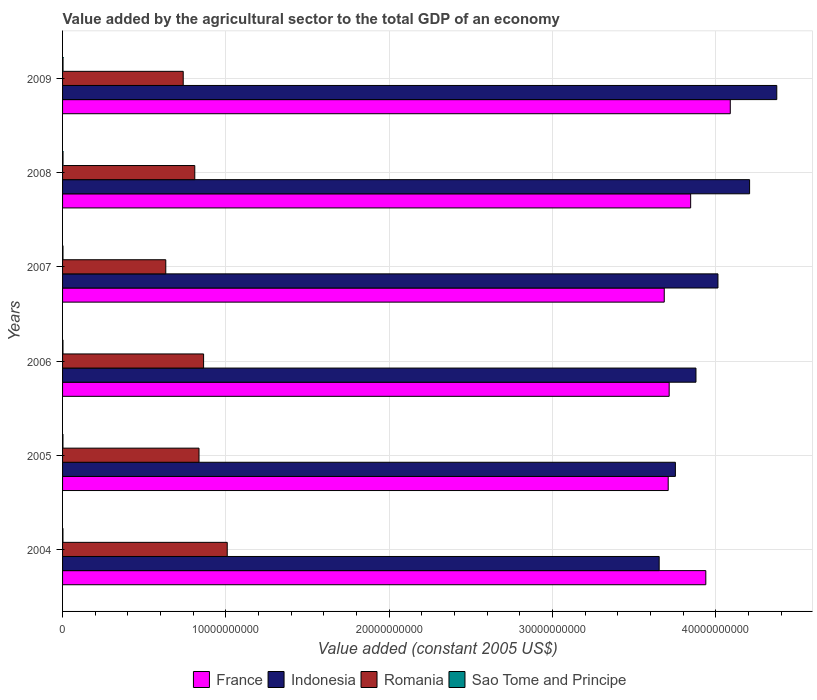How many different coloured bars are there?
Give a very brief answer. 4. How many groups of bars are there?
Your answer should be very brief. 6. Are the number of bars on each tick of the Y-axis equal?
Your answer should be compact. Yes. How many bars are there on the 1st tick from the bottom?
Provide a succinct answer. 4. What is the label of the 5th group of bars from the top?
Ensure brevity in your answer.  2005. In how many cases, is the number of bars for a given year not equal to the number of legend labels?
Provide a succinct answer. 0. What is the value added by the agricultural sector in France in 2004?
Ensure brevity in your answer.  3.94e+1. Across all years, what is the maximum value added by the agricultural sector in Indonesia?
Keep it short and to the point. 4.37e+1. Across all years, what is the minimum value added by the agricultural sector in Romania?
Provide a succinct answer. 6.32e+09. In which year was the value added by the agricultural sector in Romania minimum?
Offer a very short reply. 2007. What is the total value added by the agricultural sector in Indonesia in the graph?
Your answer should be very brief. 2.39e+11. What is the difference between the value added by the agricultural sector in Sao Tome and Principe in 2004 and that in 2007?
Ensure brevity in your answer.  -2.40e+06. What is the difference between the value added by the agricultural sector in Indonesia in 2006 and the value added by the agricultural sector in Romania in 2005?
Offer a terse response. 3.04e+1. What is the average value added by the agricultural sector in Indonesia per year?
Provide a succinct answer. 3.98e+1. In the year 2009, what is the difference between the value added by the agricultural sector in Sao Tome and Principe and value added by the agricultural sector in France?
Your answer should be compact. -4.09e+1. In how many years, is the value added by the agricultural sector in France greater than 42000000000 US$?
Offer a terse response. 0. What is the ratio of the value added by the agricultural sector in France in 2005 to that in 2007?
Provide a succinct answer. 1.01. Is the difference between the value added by the agricultural sector in Sao Tome and Principe in 2005 and 2009 greater than the difference between the value added by the agricultural sector in France in 2005 and 2009?
Keep it short and to the point. Yes. What is the difference between the highest and the second highest value added by the agricultural sector in Sao Tome and Principe?
Offer a terse response. 1.07e+06. What is the difference between the highest and the lowest value added by the agricultural sector in France?
Your response must be concise. 4.04e+09. Is the sum of the value added by the agricultural sector in Sao Tome and Principe in 2007 and 2009 greater than the maximum value added by the agricultural sector in Indonesia across all years?
Your answer should be very brief. No. Is it the case that in every year, the sum of the value added by the agricultural sector in Indonesia and value added by the agricultural sector in Romania is greater than the sum of value added by the agricultural sector in Sao Tome and Principe and value added by the agricultural sector in France?
Offer a very short reply. No. Is it the case that in every year, the sum of the value added by the agricultural sector in Sao Tome and Principe and value added by the agricultural sector in Romania is greater than the value added by the agricultural sector in France?
Your answer should be compact. No. Are the values on the major ticks of X-axis written in scientific E-notation?
Your answer should be compact. No. Does the graph contain any zero values?
Give a very brief answer. No. Does the graph contain grids?
Provide a short and direct response. Yes. Where does the legend appear in the graph?
Offer a terse response. Bottom center. How many legend labels are there?
Your answer should be compact. 4. What is the title of the graph?
Keep it short and to the point. Value added by the agricultural sector to the total GDP of an economy. Does "Nigeria" appear as one of the legend labels in the graph?
Keep it short and to the point. No. What is the label or title of the X-axis?
Your answer should be compact. Value added (constant 2005 US$). What is the label or title of the Y-axis?
Make the answer very short. Years. What is the Value added (constant 2005 US$) of France in 2004?
Your answer should be compact. 3.94e+1. What is the Value added (constant 2005 US$) of Indonesia in 2004?
Offer a very short reply. 3.65e+1. What is the Value added (constant 2005 US$) in Romania in 2004?
Make the answer very short. 1.01e+1. What is the Value added (constant 2005 US$) in Sao Tome and Principe in 2004?
Give a very brief answer. 2.29e+07. What is the Value added (constant 2005 US$) of France in 2005?
Offer a very short reply. 3.71e+1. What is the Value added (constant 2005 US$) in Indonesia in 2005?
Your answer should be very brief. 3.75e+1. What is the Value added (constant 2005 US$) of Romania in 2005?
Make the answer very short. 8.35e+09. What is the Value added (constant 2005 US$) in Sao Tome and Principe in 2005?
Provide a short and direct response. 2.33e+07. What is the Value added (constant 2005 US$) of France in 2006?
Your response must be concise. 3.71e+1. What is the Value added (constant 2005 US$) in Indonesia in 2006?
Provide a short and direct response. 3.88e+1. What is the Value added (constant 2005 US$) in Romania in 2006?
Your answer should be compact. 8.64e+09. What is the Value added (constant 2005 US$) of Sao Tome and Principe in 2006?
Make the answer very short. 2.46e+07. What is the Value added (constant 2005 US$) of France in 2007?
Offer a terse response. 3.68e+1. What is the Value added (constant 2005 US$) of Indonesia in 2007?
Your response must be concise. 4.01e+1. What is the Value added (constant 2005 US$) in Romania in 2007?
Your answer should be very brief. 6.32e+09. What is the Value added (constant 2005 US$) of Sao Tome and Principe in 2007?
Give a very brief answer. 2.53e+07. What is the Value added (constant 2005 US$) of France in 2008?
Your answer should be very brief. 3.85e+1. What is the Value added (constant 2005 US$) of Indonesia in 2008?
Give a very brief answer. 4.21e+1. What is the Value added (constant 2005 US$) of Romania in 2008?
Your answer should be compact. 8.10e+09. What is the Value added (constant 2005 US$) of Sao Tome and Principe in 2008?
Give a very brief answer. 2.75e+07. What is the Value added (constant 2005 US$) of France in 2009?
Your response must be concise. 4.09e+1. What is the Value added (constant 2005 US$) in Indonesia in 2009?
Offer a very short reply. 4.37e+1. What is the Value added (constant 2005 US$) of Romania in 2009?
Provide a short and direct response. 7.39e+09. What is the Value added (constant 2005 US$) in Sao Tome and Principe in 2009?
Provide a short and direct response. 2.85e+07. Across all years, what is the maximum Value added (constant 2005 US$) in France?
Your answer should be very brief. 4.09e+1. Across all years, what is the maximum Value added (constant 2005 US$) in Indonesia?
Ensure brevity in your answer.  4.37e+1. Across all years, what is the maximum Value added (constant 2005 US$) of Romania?
Keep it short and to the point. 1.01e+1. Across all years, what is the maximum Value added (constant 2005 US$) of Sao Tome and Principe?
Your response must be concise. 2.85e+07. Across all years, what is the minimum Value added (constant 2005 US$) of France?
Your answer should be very brief. 3.68e+1. Across all years, what is the minimum Value added (constant 2005 US$) of Indonesia?
Keep it short and to the point. 3.65e+1. Across all years, what is the minimum Value added (constant 2005 US$) in Romania?
Offer a terse response. 6.32e+09. Across all years, what is the minimum Value added (constant 2005 US$) in Sao Tome and Principe?
Your answer should be very brief. 2.29e+07. What is the total Value added (constant 2005 US$) in France in the graph?
Ensure brevity in your answer.  2.30e+11. What is the total Value added (constant 2005 US$) of Indonesia in the graph?
Your answer should be very brief. 2.39e+11. What is the total Value added (constant 2005 US$) in Romania in the graph?
Your answer should be compact. 4.89e+1. What is the total Value added (constant 2005 US$) in Sao Tome and Principe in the graph?
Provide a succinct answer. 1.52e+08. What is the difference between the Value added (constant 2005 US$) in France in 2004 and that in 2005?
Your response must be concise. 2.30e+09. What is the difference between the Value added (constant 2005 US$) in Indonesia in 2004 and that in 2005?
Make the answer very short. -9.93e+08. What is the difference between the Value added (constant 2005 US$) in Romania in 2004 and that in 2005?
Your answer should be very brief. 1.73e+09. What is the difference between the Value added (constant 2005 US$) of Sao Tome and Principe in 2004 and that in 2005?
Keep it short and to the point. -3.63e+05. What is the difference between the Value added (constant 2005 US$) in France in 2004 and that in 2006?
Offer a very short reply. 2.24e+09. What is the difference between the Value added (constant 2005 US$) in Indonesia in 2004 and that in 2006?
Offer a very short reply. -2.25e+09. What is the difference between the Value added (constant 2005 US$) in Romania in 2004 and that in 2006?
Provide a short and direct response. 1.45e+09. What is the difference between the Value added (constant 2005 US$) in Sao Tome and Principe in 2004 and that in 2006?
Provide a succinct answer. -1.74e+06. What is the difference between the Value added (constant 2005 US$) of France in 2004 and that in 2007?
Keep it short and to the point. 2.54e+09. What is the difference between the Value added (constant 2005 US$) in Indonesia in 2004 and that in 2007?
Keep it short and to the point. -3.60e+09. What is the difference between the Value added (constant 2005 US$) of Romania in 2004 and that in 2007?
Ensure brevity in your answer.  3.76e+09. What is the difference between the Value added (constant 2005 US$) of Sao Tome and Principe in 2004 and that in 2007?
Your answer should be very brief. -2.40e+06. What is the difference between the Value added (constant 2005 US$) of France in 2004 and that in 2008?
Give a very brief answer. 9.28e+08. What is the difference between the Value added (constant 2005 US$) of Indonesia in 2004 and that in 2008?
Your answer should be very brief. -5.54e+09. What is the difference between the Value added (constant 2005 US$) in Romania in 2004 and that in 2008?
Make the answer very short. 1.99e+09. What is the difference between the Value added (constant 2005 US$) of Sao Tome and Principe in 2004 and that in 2008?
Provide a short and direct response. -4.57e+06. What is the difference between the Value added (constant 2005 US$) in France in 2004 and that in 2009?
Offer a very short reply. -1.50e+09. What is the difference between the Value added (constant 2005 US$) of Indonesia in 2004 and that in 2009?
Your response must be concise. -7.20e+09. What is the difference between the Value added (constant 2005 US$) in Romania in 2004 and that in 2009?
Offer a very short reply. 2.70e+09. What is the difference between the Value added (constant 2005 US$) in Sao Tome and Principe in 2004 and that in 2009?
Provide a succinct answer. -5.65e+06. What is the difference between the Value added (constant 2005 US$) in France in 2005 and that in 2006?
Provide a short and direct response. -5.91e+07. What is the difference between the Value added (constant 2005 US$) in Indonesia in 2005 and that in 2006?
Ensure brevity in your answer.  -1.26e+09. What is the difference between the Value added (constant 2005 US$) of Romania in 2005 and that in 2006?
Keep it short and to the point. -2.81e+08. What is the difference between the Value added (constant 2005 US$) of Sao Tome and Principe in 2005 and that in 2006?
Your answer should be very brief. -1.38e+06. What is the difference between the Value added (constant 2005 US$) in France in 2005 and that in 2007?
Make the answer very short. 2.43e+08. What is the difference between the Value added (constant 2005 US$) of Indonesia in 2005 and that in 2007?
Offer a very short reply. -2.61e+09. What is the difference between the Value added (constant 2005 US$) in Romania in 2005 and that in 2007?
Ensure brevity in your answer.  2.03e+09. What is the difference between the Value added (constant 2005 US$) of Sao Tome and Principe in 2005 and that in 2007?
Your response must be concise. -2.04e+06. What is the difference between the Value added (constant 2005 US$) in France in 2005 and that in 2008?
Provide a succinct answer. -1.37e+09. What is the difference between the Value added (constant 2005 US$) in Indonesia in 2005 and that in 2008?
Give a very brief answer. -4.54e+09. What is the difference between the Value added (constant 2005 US$) in Romania in 2005 and that in 2008?
Provide a short and direct response. 2.59e+08. What is the difference between the Value added (constant 2005 US$) of Sao Tome and Principe in 2005 and that in 2008?
Keep it short and to the point. -4.21e+06. What is the difference between the Value added (constant 2005 US$) of France in 2005 and that in 2009?
Offer a terse response. -3.80e+09. What is the difference between the Value added (constant 2005 US$) in Indonesia in 2005 and that in 2009?
Give a very brief answer. -6.21e+09. What is the difference between the Value added (constant 2005 US$) in Romania in 2005 and that in 2009?
Offer a very short reply. 9.67e+08. What is the difference between the Value added (constant 2005 US$) in Sao Tome and Principe in 2005 and that in 2009?
Provide a short and direct response. -5.28e+06. What is the difference between the Value added (constant 2005 US$) of France in 2006 and that in 2007?
Provide a short and direct response. 3.02e+08. What is the difference between the Value added (constant 2005 US$) of Indonesia in 2006 and that in 2007?
Your response must be concise. -1.35e+09. What is the difference between the Value added (constant 2005 US$) in Romania in 2006 and that in 2007?
Make the answer very short. 2.31e+09. What is the difference between the Value added (constant 2005 US$) in Sao Tome and Principe in 2006 and that in 2007?
Your response must be concise. -6.63e+05. What is the difference between the Value added (constant 2005 US$) in France in 2006 and that in 2008?
Keep it short and to the point. -1.31e+09. What is the difference between the Value added (constant 2005 US$) of Indonesia in 2006 and that in 2008?
Make the answer very short. -3.28e+09. What is the difference between the Value added (constant 2005 US$) in Romania in 2006 and that in 2008?
Ensure brevity in your answer.  5.40e+08. What is the difference between the Value added (constant 2005 US$) in Sao Tome and Principe in 2006 and that in 2008?
Offer a very short reply. -2.84e+06. What is the difference between the Value added (constant 2005 US$) of France in 2006 and that in 2009?
Give a very brief answer. -3.74e+09. What is the difference between the Value added (constant 2005 US$) in Indonesia in 2006 and that in 2009?
Your answer should be very brief. -4.95e+09. What is the difference between the Value added (constant 2005 US$) of Romania in 2006 and that in 2009?
Your response must be concise. 1.25e+09. What is the difference between the Value added (constant 2005 US$) in Sao Tome and Principe in 2006 and that in 2009?
Your answer should be very brief. -3.91e+06. What is the difference between the Value added (constant 2005 US$) in France in 2007 and that in 2008?
Give a very brief answer. -1.62e+09. What is the difference between the Value added (constant 2005 US$) of Indonesia in 2007 and that in 2008?
Keep it short and to the point. -1.94e+09. What is the difference between the Value added (constant 2005 US$) in Romania in 2007 and that in 2008?
Ensure brevity in your answer.  -1.78e+09. What is the difference between the Value added (constant 2005 US$) in Sao Tome and Principe in 2007 and that in 2008?
Provide a short and direct response. -2.17e+06. What is the difference between the Value added (constant 2005 US$) in France in 2007 and that in 2009?
Provide a succinct answer. -4.04e+09. What is the difference between the Value added (constant 2005 US$) in Indonesia in 2007 and that in 2009?
Provide a succinct answer. -3.60e+09. What is the difference between the Value added (constant 2005 US$) in Romania in 2007 and that in 2009?
Keep it short and to the point. -1.07e+09. What is the difference between the Value added (constant 2005 US$) in Sao Tome and Principe in 2007 and that in 2009?
Provide a succinct answer. -3.25e+06. What is the difference between the Value added (constant 2005 US$) of France in 2008 and that in 2009?
Your answer should be compact. -2.43e+09. What is the difference between the Value added (constant 2005 US$) in Indonesia in 2008 and that in 2009?
Give a very brief answer. -1.66e+09. What is the difference between the Value added (constant 2005 US$) of Romania in 2008 and that in 2009?
Your answer should be compact. 7.08e+08. What is the difference between the Value added (constant 2005 US$) of Sao Tome and Principe in 2008 and that in 2009?
Your answer should be very brief. -1.07e+06. What is the difference between the Value added (constant 2005 US$) in France in 2004 and the Value added (constant 2005 US$) in Indonesia in 2005?
Your answer should be compact. 1.86e+09. What is the difference between the Value added (constant 2005 US$) of France in 2004 and the Value added (constant 2005 US$) of Romania in 2005?
Make the answer very short. 3.10e+1. What is the difference between the Value added (constant 2005 US$) in France in 2004 and the Value added (constant 2005 US$) in Sao Tome and Principe in 2005?
Your answer should be very brief. 3.94e+1. What is the difference between the Value added (constant 2005 US$) of Indonesia in 2004 and the Value added (constant 2005 US$) of Romania in 2005?
Your answer should be very brief. 2.82e+1. What is the difference between the Value added (constant 2005 US$) in Indonesia in 2004 and the Value added (constant 2005 US$) in Sao Tome and Principe in 2005?
Offer a very short reply. 3.65e+1. What is the difference between the Value added (constant 2005 US$) in Romania in 2004 and the Value added (constant 2005 US$) in Sao Tome and Principe in 2005?
Ensure brevity in your answer.  1.01e+1. What is the difference between the Value added (constant 2005 US$) of France in 2004 and the Value added (constant 2005 US$) of Indonesia in 2006?
Offer a terse response. 6.03e+08. What is the difference between the Value added (constant 2005 US$) in France in 2004 and the Value added (constant 2005 US$) in Romania in 2006?
Your answer should be compact. 3.08e+1. What is the difference between the Value added (constant 2005 US$) in France in 2004 and the Value added (constant 2005 US$) in Sao Tome and Principe in 2006?
Offer a very short reply. 3.94e+1. What is the difference between the Value added (constant 2005 US$) in Indonesia in 2004 and the Value added (constant 2005 US$) in Romania in 2006?
Offer a very short reply. 2.79e+1. What is the difference between the Value added (constant 2005 US$) in Indonesia in 2004 and the Value added (constant 2005 US$) in Sao Tome and Principe in 2006?
Ensure brevity in your answer.  3.65e+1. What is the difference between the Value added (constant 2005 US$) of Romania in 2004 and the Value added (constant 2005 US$) of Sao Tome and Principe in 2006?
Give a very brief answer. 1.01e+1. What is the difference between the Value added (constant 2005 US$) of France in 2004 and the Value added (constant 2005 US$) of Indonesia in 2007?
Your answer should be compact. -7.43e+08. What is the difference between the Value added (constant 2005 US$) in France in 2004 and the Value added (constant 2005 US$) in Romania in 2007?
Keep it short and to the point. 3.31e+1. What is the difference between the Value added (constant 2005 US$) of France in 2004 and the Value added (constant 2005 US$) of Sao Tome and Principe in 2007?
Offer a terse response. 3.94e+1. What is the difference between the Value added (constant 2005 US$) of Indonesia in 2004 and the Value added (constant 2005 US$) of Romania in 2007?
Offer a terse response. 3.02e+1. What is the difference between the Value added (constant 2005 US$) in Indonesia in 2004 and the Value added (constant 2005 US$) in Sao Tome and Principe in 2007?
Your answer should be compact. 3.65e+1. What is the difference between the Value added (constant 2005 US$) in Romania in 2004 and the Value added (constant 2005 US$) in Sao Tome and Principe in 2007?
Give a very brief answer. 1.01e+1. What is the difference between the Value added (constant 2005 US$) of France in 2004 and the Value added (constant 2005 US$) of Indonesia in 2008?
Offer a very short reply. -2.68e+09. What is the difference between the Value added (constant 2005 US$) in France in 2004 and the Value added (constant 2005 US$) in Romania in 2008?
Provide a succinct answer. 3.13e+1. What is the difference between the Value added (constant 2005 US$) in France in 2004 and the Value added (constant 2005 US$) in Sao Tome and Principe in 2008?
Offer a very short reply. 3.94e+1. What is the difference between the Value added (constant 2005 US$) of Indonesia in 2004 and the Value added (constant 2005 US$) of Romania in 2008?
Keep it short and to the point. 2.84e+1. What is the difference between the Value added (constant 2005 US$) of Indonesia in 2004 and the Value added (constant 2005 US$) of Sao Tome and Principe in 2008?
Your answer should be compact. 3.65e+1. What is the difference between the Value added (constant 2005 US$) in Romania in 2004 and the Value added (constant 2005 US$) in Sao Tome and Principe in 2008?
Provide a succinct answer. 1.01e+1. What is the difference between the Value added (constant 2005 US$) of France in 2004 and the Value added (constant 2005 US$) of Indonesia in 2009?
Give a very brief answer. -4.35e+09. What is the difference between the Value added (constant 2005 US$) in France in 2004 and the Value added (constant 2005 US$) in Romania in 2009?
Provide a succinct answer. 3.20e+1. What is the difference between the Value added (constant 2005 US$) in France in 2004 and the Value added (constant 2005 US$) in Sao Tome and Principe in 2009?
Offer a terse response. 3.94e+1. What is the difference between the Value added (constant 2005 US$) of Indonesia in 2004 and the Value added (constant 2005 US$) of Romania in 2009?
Your answer should be very brief. 2.91e+1. What is the difference between the Value added (constant 2005 US$) in Indonesia in 2004 and the Value added (constant 2005 US$) in Sao Tome and Principe in 2009?
Your response must be concise. 3.65e+1. What is the difference between the Value added (constant 2005 US$) of Romania in 2004 and the Value added (constant 2005 US$) of Sao Tome and Principe in 2009?
Provide a short and direct response. 1.01e+1. What is the difference between the Value added (constant 2005 US$) of France in 2005 and the Value added (constant 2005 US$) of Indonesia in 2006?
Your response must be concise. -1.70e+09. What is the difference between the Value added (constant 2005 US$) in France in 2005 and the Value added (constant 2005 US$) in Romania in 2006?
Provide a short and direct response. 2.84e+1. What is the difference between the Value added (constant 2005 US$) in France in 2005 and the Value added (constant 2005 US$) in Sao Tome and Principe in 2006?
Your answer should be very brief. 3.71e+1. What is the difference between the Value added (constant 2005 US$) of Indonesia in 2005 and the Value added (constant 2005 US$) of Romania in 2006?
Provide a succinct answer. 2.89e+1. What is the difference between the Value added (constant 2005 US$) in Indonesia in 2005 and the Value added (constant 2005 US$) in Sao Tome and Principe in 2006?
Your answer should be compact. 3.75e+1. What is the difference between the Value added (constant 2005 US$) of Romania in 2005 and the Value added (constant 2005 US$) of Sao Tome and Principe in 2006?
Ensure brevity in your answer.  8.33e+09. What is the difference between the Value added (constant 2005 US$) in France in 2005 and the Value added (constant 2005 US$) in Indonesia in 2007?
Offer a very short reply. -3.05e+09. What is the difference between the Value added (constant 2005 US$) in France in 2005 and the Value added (constant 2005 US$) in Romania in 2007?
Offer a very short reply. 3.08e+1. What is the difference between the Value added (constant 2005 US$) in France in 2005 and the Value added (constant 2005 US$) in Sao Tome and Principe in 2007?
Keep it short and to the point. 3.71e+1. What is the difference between the Value added (constant 2005 US$) of Indonesia in 2005 and the Value added (constant 2005 US$) of Romania in 2007?
Provide a short and direct response. 3.12e+1. What is the difference between the Value added (constant 2005 US$) in Indonesia in 2005 and the Value added (constant 2005 US$) in Sao Tome and Principe in 2007?
Your response must be concise. 3.75e+1. What is the difference between the Value added (constant 2005 US$) of Romania in 2005 and the Value added (constant 2005 US$) of Sao Tome and Principe in 2007?
Keep it short and to the point. 8.33e+09. What is the difference between the Value added (constant 2005 US$) of France in 2005 and the Value added (constant 2005 US$) of Indonesia in 2008?
Your response must be concise. -4.98e+09. What is the difference between the Value added (constant 2005 US$) of France in 2005 and the Value added (constant 2005 US$) of Romania in 2008?
Make the answer very short. 2.90e+1. What is the difference between the Value added (constant 2005 US$) in France in 2005 and the Value added (constant 2005 US$) in Sao Tome and Principe in 2008?
Offer a terse response. 3.71e+1. What is the difference between the Value added (constant 2005 US$) of Indonesia in 2005 and the Value added (constant 2005 US$) of Romania in 2008?
Make the answer very short. 2.94e+1. What is the difference between the Value added (constant 2005 US$) of Indonesia in 2005 and the Value added (constant 2005 US$) of Sao Tome and Principe in 2008?
Give a very brief answer. 3.75e+1. What is the difference between the Value added (constant 2005 US$) of Romania in 2005 and the Value added (constant 2005 US$) of Sao Tome and Principe in 2008?
Your answer should be compact. 8.33e+09. What is the difference between the Value added (constant 2005 US$) of France in 2005 and the Value added (constant 2005 US$) of Indonesia in 2009?
Keep it short and to the point. -6.65e+09. What is the difference between the Value added (constant 2005 US$) in France in 2005 and the Value added (constant 2005 US$) in Romania in 2009?
Ensure brevity in your answer.  2.97e+1. What is the difference between the Value added (constant 2005 US$) in France in 2005 and the Value added (constant 2005 US$) in Sao Tome and Principe in 2009?
Offer a terse response. 3.71e+1. What is the difference between the Value added (constant 2005 US$) of Indonesia in 2005 and the Value added (constant 2005 US$) of Romania in 2009?
Ensure brevity in your answer.  3.01e+1. What is the difference between the Value added (constant 2005 US$) in Indonesia in 2005 and the Value added (constant 2005 US$) in Sao Tome and Principe in 2009?
Offer a very short reply. 3.75e+1. What is the difference between the Value added (constant 2005 US$) of Romania in 2005 and the Value added (constant 2005 US$) of Sao Tome and Principe in 2009?
Make the answer very short. 8.33e+09. What is the difference between the Value added (constant 2005 US$) in France in 2006 and the Value added (constant 2005 US$) in Indonesia in 2007?
Your answer should be very brief. -2.99e+09. What is the difference between the Value added (constant 2005 US$) of France in 2006 and the Value added (constant 2005 US$) of Romania in 2007?
Offer a terse response. 3.08e+1. What is the difference between the Value added (constant 2005 US$) of France in 2006 and the Value added (constant 2005 US$) of Sao Tome and Principe in 2007?
Provide a succinct answer. 3.71e+1. What is the difference between the Value added (constant 2005 US$) of Indonesia in 2006 and the Value added (constant 2005 US$) of Romania in 2007?
Provide a short and direct response. 3.25e+1. What is the difference between the Value added (constant 2005 US$) in Indonesia in 2006 and the Value added (constant 2005 US$) in Sao Tome and Principe in 2007?
Ensure brevity in your answer.  3.88e+1. What is the difference between the Value added (constant 2005 US$) of Romania in 2006 and the Value added (constant 2005 US$) of Sao Tome and Principe in 2007?
Give a very brief answer. 8.61e+09. What is the difference between the Value added (constant 2005 US$) of France in 2006 and the Value added (constant 2005 US$) of Indonesia in 2008?
Your response must be concise. -4.92e+09. What is the difference between the Value added (constant 2005 US$) in France in 2006 and the Value added (constant 2005 US$) in Romania in 2008?
Ensure brevity in your answer.  2.90e+1. What is the difference between the Value added (constant 2005 US$) of France in 2006 and the Value added (constant 2005 US$) of Sao Tome and Principe in 2008?
Offer a very short reply. 3.71e+1. What is the difference between the Value added (constant 2005 US$) of Indonesia in 2006 and the Value added (constant 2005 US$) of Romania in 2008?
Make the answer very short. 3.07e+1. What is the difference between the Value added (constant 2005 US$) in Indonesia in 2006 and the Value added (constant 2005 US$) in Sao Tome and Principe in 2008?
Your answer should be very brief. 3.88e+1. What is the difference between the Value added (constant 2005 US$) in Romania in 2006 and the Value added (constant 2005 US$) in Sao Tome and Principe in 2008?
Offer a terse response. 8.61e+09. What is the difference between the Value added (constant 2005 US$) in France in 2006 and the Value added (constant 2005 US$) in Indonesia in 2009?
Your answer should be very brief. -6.59e+09. What is the difference between the Value added (constant 2005 US$) in France in 2006 and the Value added (constant 2005 US$) in Romania in 2009?
Provide a short and direct response. 2.98e+1. What is the difference between the Value added (constant 2005 US$) of France in 2006 and the Value added (constant 2005 US$) of Sao Tome and Principe in 2009?
Provide a succinct answer. 3.71e+1. What is the difference between the Value added (constant 2005 US$) of Indonesia in 2006 and the Value added (constant 2005 US$) of Romania in 2009?
Your response must be concise. 3.14e+1. What is the difference between the Value added (constant 2005 US$) in Indonesia in 2006 and the Value added (constant 2005 US$) in Sao Tome and Principe in 2009?
Your response must be concise. 3.88e+1. What is the difference between the Value added (constant 2005 US$) in Romania in 2006 and the Value added (constant 2005 US$) in Sao Tome and Principe in 2009?
Ensure brevity in your answer.  8.61e+09. What is the difference between the Value added (constant 2005 US$) in France in 2007 and the Value added (constant 2005 US$) in Indonesia in 2008?
Offer a very short reply. -5.23e+09. What is the difference between the Value added (constant 2005 US$) of France in 2007 and the Value added (constant 2005 US$) of Romania in 2008?
Provide a succinct answer. 2.87e+1. What is the difference between the Value added (constant 2005 US$) in France in 2007 and the Value added (constant 2005 US$) in Sao Tome and Principe in 2008?
Provide a succinct answer. 3.68e+1. What is the difference between the Value added (constant 2005 US$) in Indonesia in 2007 and the Value added (constant 2005 US$) in Romania in 2008?
Provide a short and direct response. 3.20e+1. What is the difference between the Value added (constant 2005 US$) of Indonesia in 2007 and the Value added (constant 2005 US$) of Sao Tome and Principe in 2008?
Ensure brevity in your answer.  4.01e+1. What is the difference between the Value added (constant 2005 US$) in Romania in 2007 and the Value added (constant 2005 US$) in Sao Tome and Principe in 2008?
Provide a short and direct response. 6.29e+09. What is the difference between the Value added (constant 2005 US$) of France in 2007 and the Value added (constant 2005 US$) of Indonesia in 2009?
Make the answer very short. -6.89e+09. What is the difference between the Value added (constant 2005 US$) in France in 2007 and the Value added (constant 2005 US$) in Romania in 2009?
Provide a short and direct response. 2.95e+1. What is the difference between the Value added (constant 2005 US$) of France in 2007 and the Value added (constant 2005 US$) of Sao Tome and Principe in 2009?
Ensure brevity in your answer.  3.68e+1. What is the difference between the Value added (constant 2005 US$) in Indonesia in 2007 and the Value added (constant 2005 US$) in Romania in 2009?
Offer a very short reply. 3.27e+1. What is the difference between the Value added (constant 2005 US$) of Indonesia in 2007 and the Value added (constant 2005 US$) of Sao Tome and Principe in 2009?
Offer a terse response. 4.01e+1. What is the difference between the Value added (constant 2005 US$) of Romania in 2007 and the Value added (constant 2005 US$) of Sao Tome and Principe in 2009?
Your answer should be compact. 6.29e+09. What is the difference between the Value added (constant 2005 US$) in France in 2008 and the Value added (constant 2005 US$) in Indonesia in 2009?
Your response must be concise. -5.27e+09. What is the difference between the Value added (constant 2005 US$) of France in 2008 and the Value added (constant 2005 US$) of Romania in 2009?
Ensure brevity in your answer.  3.11e+1. What is the difference between the Value added (constant 2005 US$) in France in 2008 and the Value added (constant 2005 US$) in Sao Tome and Principe in 2009?
Make the answer very short. 3.84e+1. What is the difference between the Value added (constant 2005 US$) of Indonesia in 2008 and the Value added (constant 2005 US$) of Romania in 2009?
Keep it short and to the point. 3.47e+1. What is the difference between the Value added (constant 2005 US$) in Indonesia in 2008 and the Value added (constant 2005 US$) in Sao Tome and Principe in 2009?
Ensure brevity in your answer.  4.20e+1. What is the difference between the Value added (constant 2005 US$) of Romania in 2008 and the Value added (constant 2005 US$) of Sao Tome and Principe in 2009?
Keep it short and to the point. 8.07e+09. What is the average Value added (constant 2005 US$) of France per year?
Keep it short and to the point. 3.83e+1. What is the average Value added (constant 2005 US$) of Indonesia per year?
Your response must be concise. 3.98e+1. What is the average Value added (constant 2005 US$) of Romania per year?
Your answer should be compact. 8.15e+09. What is the average Value added (constant 2005 US$) in Sao Tome and Principe per year?
Offer a very short reply. 2.53e+07. In the year 2004, what is the difference between the Value added (constant 2005 US$) of France and Value added (constant 2005 US$) of Indonesia?
Provide a succinct answer. 2.86e+09. In the year 2004, what is the difference between the Value added (constant 2005 US$) of France and Value added (constant 2005 US$) of Romania?
Your response must be concise. 2.93e+1. In the year 2004, what is the difference between the Value added (constant 2005 US$) in France and Value added (constant 2005 US$) in Sao Tome and Principe?
Ensure brevity in your answer.  3.94e+1. In the year 2004, what is the difference between the Value added (constant 2005 US$) in Indonesia and Value added (constant 2005 US$) in Romania?
Provide a short and direct response. 2.64e+1. In the year 2004, what is the difference between the Value added (constant 2005 US$) of Indonesia and Value added (constant 2005 US$) of Sao Tome and Principe?
Offer a very short reply. 3.65e+1. In the year 2004, what is the difference between the Value added (constant 2005 US$) of Romania and Value added (constant 2005 US$) of Sao Tome and Principe?
Keep it short and to the point. 1.01e+1. In the year 2005, what is the difference between the Value added (constant 2005 US$) of France and Value added (constant 2005 US$) of Indonesia?
Your response must be concise. -4.40e+08. In the year 2005, what is the difference between the Value added (constant 2005 US$) of France and Value added (constant 2005 US$) of Romania?
Give a very brief answer. 2.87e+1. In the year 2005, what is the difference between the Value added (constant 2005 US$) in France and Value added (constant 2005 US$) in Sao Tome and Principe?
Your answer should be very brief. 3.71e+1. In the year 2005, what is the difference between the Value added (constant 2005 US$) of Indonesia and Value added (constant 2005 US$) of Romania?
Provide a succinct answer. 2.92e+1. In the year 2005, what is the difference between the Value added (constant 2005 US$) of Indonesia and Value added (constant 2005 US$) of Sao Tome and Principe?
Keep it short and to the point. 3.75e+1. In the year 2005, what is the difference between the Value added (constant 2005 US$) in Romania and Value added (constant 2005 US$) in Sao Tome and Principe?
Make the answer very short. 8.33e+09. In the year 2006, what is the difference between the Value added (constant 2005 US$) in France and Value added (constant 2005 US$) in Indonesia?
Your answer should be compact. -1.64e+09. In the year 2006, what is the difference between the Value added (constant 2005 US$) of France and Value added (constant 2005 US$) of Romania?
Give a very brief answer. 2.85e+1. In the year 2006, what is the difference between the Value added (constant 2005 US$) in France and Value added (constant 2005 US$) in Sao Tome and Principe?
Make the answer very short. 3.71e+1. In the year 2006, what is the difference between the Value added (constant 2005 US$) of Indonesia and Value added (constant 2005 US$) of Romania?
Ensure brevity in your answer.  3.01e+1. In the year 2006, what is the difference between the Value added (constant 2005 US$) in Indonesia and Value added (constant 2005 US$) in Sao Tome and Principe?
Ensure brevity in your answer.  3.88e+1. In the year 2006, what is the difference between the Value added (constant 2005 US$) in Romania and Value added (constant 2005 US$) in Sao Tome and Principe?
Provide a short and direct response. 8.61e+09. In the year 2007, what is the difference between the Value added (constant 2005 US$) of France and Value added (constant 2005 US$) of Indonesia?
Offer a very short reply. -3.29e+09. In the year 2007, what is the difference between the Value added (constant 2005 US$) in France and Value added (constant 2005 US$) in Romania?
Give a very brief answer. 3.05e+1. In the year 2007, what is the difference between the Value added (constant 2005 US$) in France and Value added (constant 2005 US$) in Sao Tome and Principe?
Your answer should be very brief. 3.68e+1. In the year 2007, what is the difference between the Value added (constant 2005 US$) of Indonesia and Value added (constant 2005 US$) of Romania?
Provide a succinct answer. 3.38e+1. In the year 2007, what is the difference between the Value added (constant 2005 US$) in Indonesia and Value added (constant 2005 US$) in Sao Tome and Principe?
Ensure brevity in your answer.  4.01e+1. In the year 2007, what is the difference between the Value added (constant 2005 US$) of Romania and Value added (constant 2005 US$) of Sao Tome and Principe?
Offer a very short reply. 6.30e+09. In the year 2008, what is the difference between the Value added (constant 2005 US$) in France and Value added (constant 2005 US$) in Indonesia?
Your answer should be very brief. -3.61e+09. In the year 2008, what is the difference between the Value added (constant 2005 US$) in France and Value added (constant 2005 US$) in Romania?
Your answer should be compact. 3.04e+1. In the year 2008, what is the difference between the Value added (constant 2005 US$) of France and Value added (constant 2005 US$) of Sao Tome and Principe?
Provide a succinct answer. 3.84e+1. In the year 2008, what is the difference between the Value added (constant 2005 US$) in Indonesia and Value added (constant 2005 US$) in Romania?
Provide a short and direct response. 3.40e+1. In the year 2008, what is the difference between the Value added (constant 2005 US$) in Indonesia and Value added (constant 2005 US$) in Sao Tome and Principe?
Make the answer very short. 4.20e+1. In the year 2008, what is the difference between the Value added (constant 2005 US$) of Romania and Value added (constant 2005 US$) of Sao Tome and Principe?
Offer a very short reply. 8.07e+09. In the year 2009, what is the difference between the Value added (constant 2005 US$) in France and Value added (constant 2005 US$) in Indonesia?
Make the answer very short. -2.85e+09. In the year 2009, what is the difference between the Value added (constant 2005 US$) in France and Value added (constant 2005 US$) in Romania?
Give a very brief answer. 3.35e+1. In the year 2009, what is the difference between the Value added (constant 2005 US$) of France and Value added (constant 2005 US$) of Sao Tome and Principe?
Your response must be concise. 4.09e+1. In the year 2009, what is the difference between the Value added (constant 2005 US$) of Indonesia and Value added (constant 2005 US$) of Romania?
Ensure brevity in your answer.  3.63e+1. In the year 2009, what is the difference between the Value added (constant 2005 US$) in Indonesia and Value added (constant 2005 US$) in Sao Tome and Principe?
Offer a terse response. 4.37e+1. In the year 2009, what is the difference between the Value added (constant 2005 US$) of Romania and Value added (constant 2005 US$) of Sao Tome and Principe?
Your answer should be compact. 7.36e+09. What is the ratio of the Value added (constant 2005 US$) of France in 2004 to that in 2005?
Offer a very short reply. 1.06. What is the ratio of the Value added (constant 2005 US$) in Indonesia in 2004 to that in 2005?
Ensure brevity in your answer.  0.97. What is the ratio of the Value added (constant 2005 US$) in Romania in 2004 to that in 2005?
Your answer should be very brief. 1.21. What is the ratio of the Value added (constant 2005 US$) of Sao Tome and Principe in 2004 to that in 2005?
Keep it short and to the point. 0.98. What is the ratio of the Value added (constant 2005 US$) in France in 2004 to that in 2006?
Keep it short and to the point. 1.06. What is the ratio of the Value added (constant 2005 US$) of Indonesia in 2004 to that in 2006?
Your answer should be compact. 0.94. What is the ratio of the Value added (constant 2005 US$) of Romania in 2004 to that in 2006?
Ensure brevity in your answer.  1.17. What is the ratio of the Value added (constant 2005 US$) of Sao Tome and Principe in 2004 to that in 2006?
Give a very brief answer. 0.93. What is the ratio of the Value added (constant 2005 US$) of France in 2004 to that in 2007?
Provide a succinct answer. 1.07. What is the ratio of the Value added (constant 2005 US$) in Indonesia in 2004 to that in 2007?
Keep it short and to the point. 0.91. What is the ratio of the Value added (constant 2005 US$) in Romania in 2004 to that in 2007?
Your answer should be very brief. 1.6. What is the ratio of the Value added (constant 2005 US$) of Sao Tome and Principe in 2004 to that in 2007?
Offer a very short reply. 0.91. What is the ratio of the Value added (constant 2005 US$) of France in 2004 to that in 2008?
Offer a very short reply. 1.02. What is the ratio of the Value added (constant 2005 US$) in Indonesia in 2004 to that in 2008?
Ensure brevity in your answer.  0.87. What is the ratio of the Value added (constant 2005 US$) in Romania in 2004 to that in 2008?
Your response must be concise. 1.25. What is the ratio of the Value added (constant 2005 US$) of Sao Tome and Principe in 2004 to that in 2008?
Provide a short and direct response. 0.83. What is the ratio of the Value added (constant 2005 US$) in France in 2004 to that in 2009?
Offer a terse response. 0.96. What is the ratio of the Value added (constant 2005 US$) of Indonesia in 2004 to that in 2009?
Your answer should be compact. 0.84. What is the ratio of the Value added (constant 2005 US$) of Romania in 2004 to that in 2009?
Provide a short and direct response. 1.36. What is the ratio of the Value added (constant 2005 US$) in Sao Tome and Principe in 2004 to that in 2009?
Your response must be concise. 0.8. What is the ratio of the Value added (constant 2005 US$) in Indonesia in 2005 to that in 2006?
Your answer should be compact. 0.97. What is the ratio of the Value added (constant 2005 US$) in Romania in 2005 to that in 2006?
Provide a short and direct response. 0.97. What is the ratio of the Value added (constant 2005 US$) of Sao Tome and Principe in 2005 to that in 2006?
Offer a very short reply. 0.94. What is the ratio of the Value added (constant 2005 US$) of France in 2005 to that in 2007?
Your answer should be compact. 1.01. What is the ratio of the Value added (constant 2005 US$) in Indonesia in 2005 to that in 2007?
Make the answer very short. 0.94. What is the ratio of the Value added (constant 2005 US$) in Romania in 2005 to that in 2007?
Your answer should be compact. 1.32. What is the ratio of the Value added (constant 2005 US$) in Sao Tome and Principe in 2005 to that in 2007?
Your answer should be very brief. 0.92. What is the ratio of the Value added (constant 2005 US$) in France in 2005 to that in 2008?
Your answer should be compact. 0.96. What is the ratio of the Value added (constant 2005 US$) in Indonesia in 2005 to that in 2008?
Provide a succinct answer. 0.89. What is the ratio of the Value added (constant 2005 US$) of Romania in 2005 to that in 2008?
Offer a terse response. 1.03. What is the ratio of the Value added (constant 2005 US$) in Sao Tome and Principe in 2005 to that in 2008?
Your response must be concise. 0.85. What is the ratio of the Value added (constant 2005 US$) in France in 2005 to that in 2009?
Give a very brief answer. 0.91. What is the ratio of the Value added (constant 2005 US$) in Indonesia in 2005 to that in 2009?
Your answer should be very brief. 0.86. What is the ratio of the Value added (constant 2005 US$) in Romania in 2005 to that in 2009?
Your answer should be compact. 1.13. What is the ratio of the Value added (constant 2005 US$) of Sao Tome and Principe in 2005 to that in 2009?
Your response must be concise. 0.81. What is the ratio of the Value added (constant 2005 US$) of France in 2006 to that in 2007?
Give a very brief answer. 1.01. What is the ratio of the Value added (constant 2005 US$) in Indonesia in 2006 to that in 2007?
Your response must be concise. 0.97. What is the ratio of the Value added (constant 2005 US$) of Romania in 2006 to that in 2007?
Your answer should be compact. 1.37. What is the ratio of the Value added (constant 2005 US$) in Sao Tome and Principe in 2006 to that in 2007?
Ensure brevity in your answer.  0.97. What is the ratio of the Value added (constant 2005 US$) of France in 2006 to that in 2008?
Make the answer very short. 0.97. What is the ratio of the Value added (constant 2005 US$) in Indonesia in 2006 to that in 2008?
Offer a terse response. 0.92. What is the ratio of the Value added (constant 2005 US$) of Romania in 2006 to that in 2008?
Give a very brief answer. 1.07. What is the ratio of the Value added (constant 2005 US$) of Sao Tome and Principe in 2006 to that in 2008?
Offer a very short reply. 0.9. What is the ratio of the Value added (constant 2005 US$) in France in 2006 to that in 2009?
Your answer should be very brief. 0.91. What is the ratio of the Value added (constant 2005 US$) in Indonesia in 2006 to that in 2009?
Offer a terse response. 0.89. What is the ratio of the Value added (constant 2005 US$) in Romania in 2006 to that in 2009?
Give a very brief answer. 1.17. What is the ratio of the Value added (constant 2005 US$) of Sao Tome and Principe in 2006 to that in 2009?
Ensure brevity in your answer.  0.86. What is the ratio of the Value added (constant 2005 US$) in France in 2007 to that in 2008?
Provide a succinct answer. 0.96. What is the ratio of the Value added (constant 2005 US$) in Indonesia in 2007 to that in 2008?
Provide a short and direct response. 0.95. What is the ratio of the Value added (constant 2005 US$) in Romania in 2007 to that in 2008?
Offer a very short reply. 0.78. What is the ratio of the Value added (constant 2005 US$) in Sao Tome and Principe in 2007 to that in 2008?
Your response must be concise. 0.92. What is the ratio of the Value added (constant 2005 US$) in France in 2007 to that in 2009?
Provide a short and direct response. 0.9. What is the ratio of the Value added (constant 2005 US$) in Indonesia in 2007 to that in 2009?
Offer a terse response. 0.92. What is the ratio of the Value added (constant 2005 US$) in Romania in 2007 to that in 2009?
Your answer should be compact. 0.86. What is the ratio of the Value added (constant 2005 US$) of Sao Tome and Principe in 2007 to that in 2009?
Your response must be concise. 0.89. What is the ratio of the Value added (constant 2005 US$) of France in 2008 to that in 2009?
Offer a very short reply. 0.94. What is the ratio of the Value added (constant 2005 US$) in Indonesia in 2008 to that in 2009?
Offer a terse response. 0.96. What is the ratio of the Value added (constant 2005 US$) of Romania in 2008 to that in 2009?
Your answer should be very brief. 1.1. What is the ratio of the Value added (constant 2005 US$) in Sao Tome and Principe in 2008 to that in 2009?
Ensure brevity in your answer.  0.96. What is the difference between the highest and the second highest Value added (constant 2005 US$) in France?
Your response must be concise. 1.50e+09. What is the difference between the highest and the second highest Value added (constant 2005 US$) of Indonesia?
Offer a very short reply. 1.66e+09. What is the difference between the highest and the second highest Value added (constant 2005 US$) of Romania?
Offer a terse response. 1.45e+09. What is the difference between the highest and the second highest Value added (constant 2005 US$) in Sao Tome and Principe?
Give a very brief answer. 1.07e+06. What is the difference between the highest and the lowest Value added (constant 2005 US$) in France?
Your answer should be very brief. 4.04e+09. What is the difference between the highest and the lowest Value added (constant 2005 US$) in Indonesia?
Provide a succinct answer. 7.20e+09. What is the difference between the highest and the lowest Value added (constant 2005 US$) in Romania?
Give a very brief answer. 3.76e+09. What is the difference between the highest and the lowest Value added (constant 2005 US$) of Sao Tome and Principe?
Give a very brief answer. 5.65e+06. 